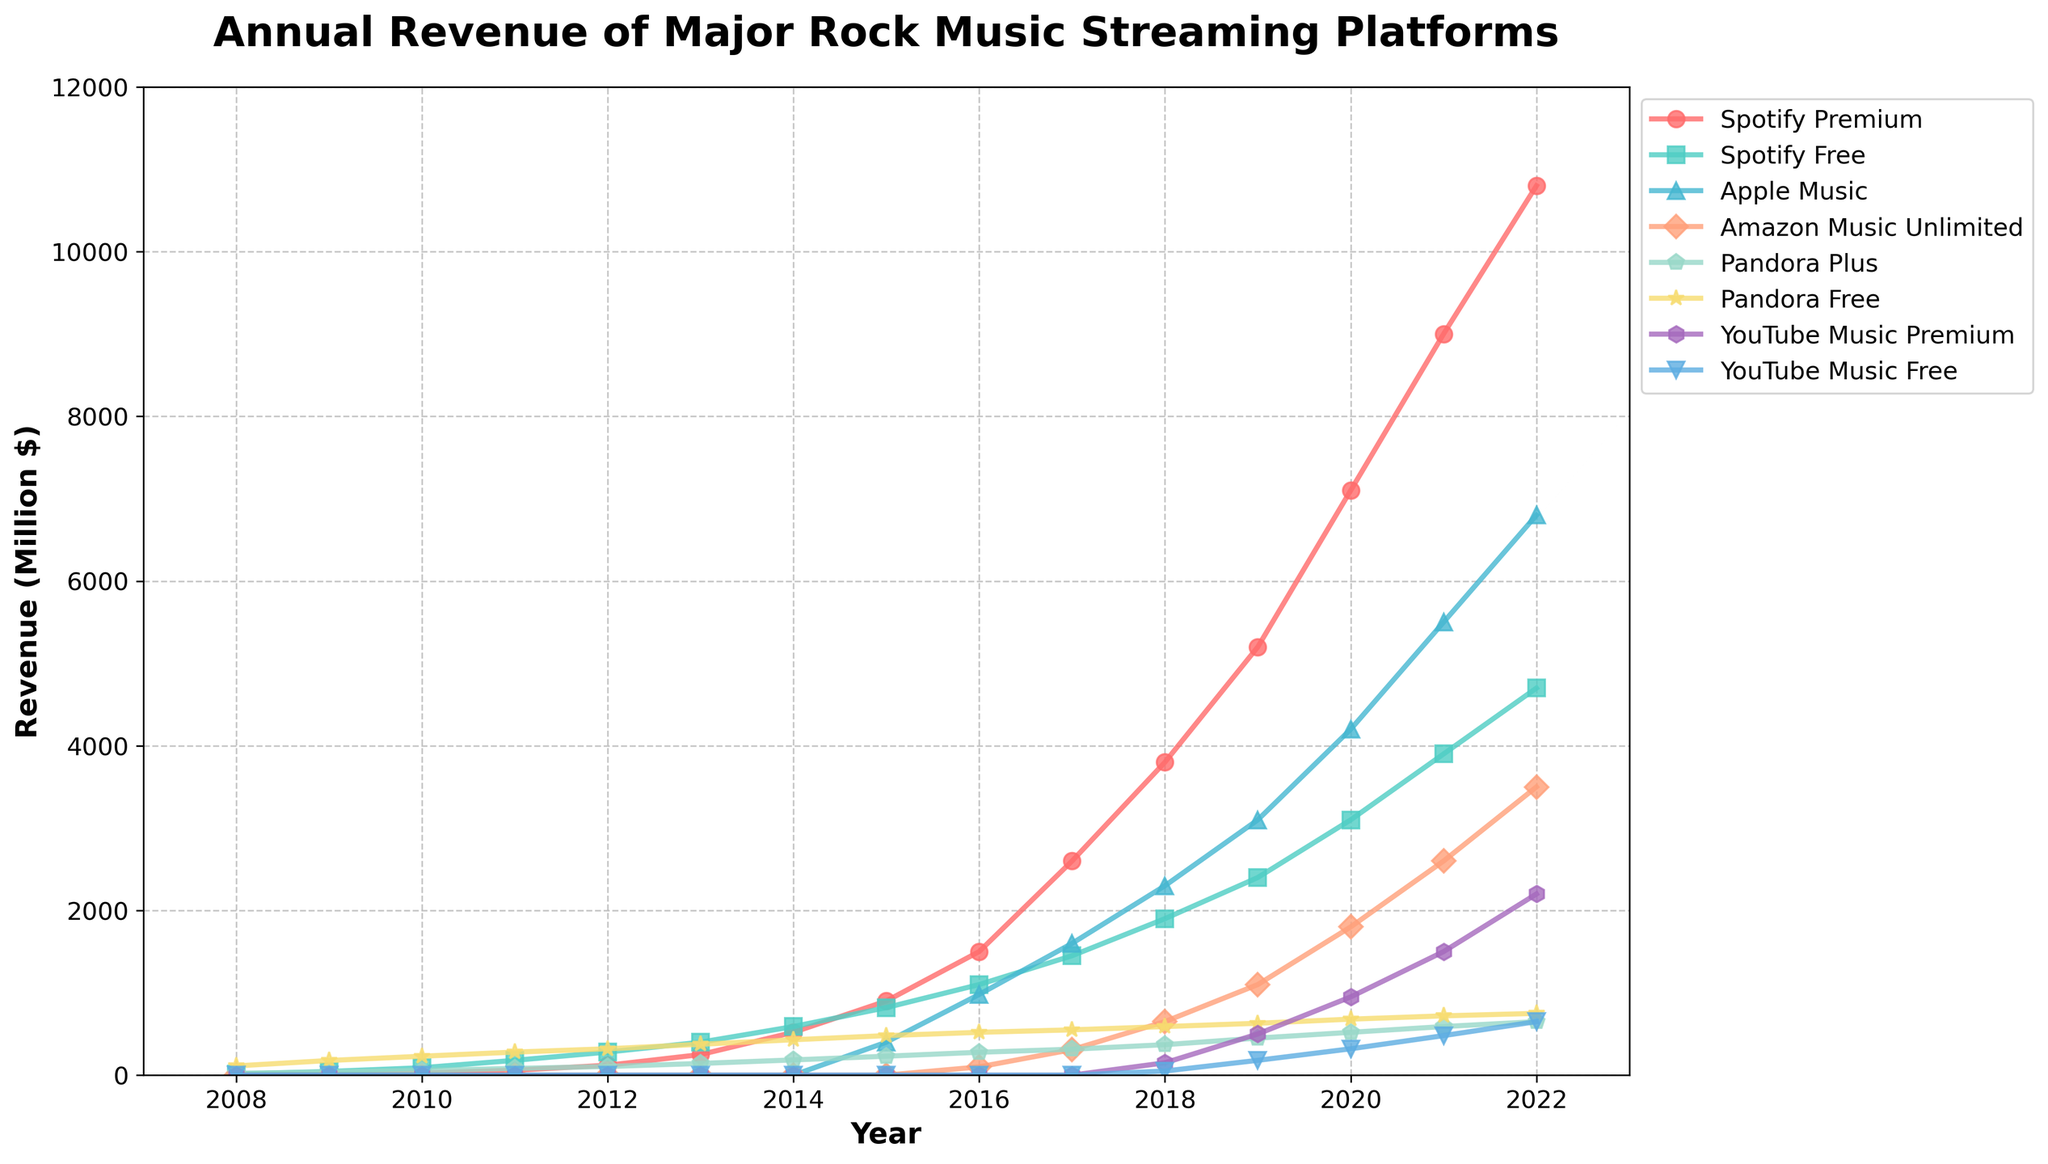What was the total revenue of Spotify in 2022? Spotify Premium had a revenue of 10800 million dollars and Spotify Free had a revenue of 4700 million dollars in 2022. Adding these together, the total revenue of Spotify in 2022 is 10800 + 4700 = 15500 million dollars.
Answer: 15500 million dollars Which platform had the highest revenue in 2020, and what was the amount? Checking each platform's revenue for 2020, Spotify Premium had the highest revenue of 7100 million dollars.
Answer: Spotify Premium, 7100 million dollars What is the difference in revenue between YouTube Music Premium and YouTube Music Free in 2021? In 2021, YouTube Music Premium had a revenue of 1500 million dollars, and YouTube Music Free had a revenue of 480 million dollars. The difference is 1500 - 480 = 1020 million dollars.
Answer: 1020 million dollars How did the revenue of Apple Music change from 2015 to 2022? In 2015, Apple Music's revenue was 400 million dollars. By 2022, it increased to 6800 million dollars. The change is 6800 - 400 = 6400 million dollars.
Answer: Increased by 6400 million dollars Which platform had the smallest revenue increase between 2019 and 2020? Comparing each platform's revenue increase: 
Spotify Premium (7100 - 5200 = 1900), 
Spotify Free (3100 - 2400 = 700), 
Apple Music (4200 - 3100 = 1100), 
Amazon Music Unlimited (1800 - 1100 = 700), 
Pandora Plus (520 - 450 = 70), 
Pandora Free (680 - 630 = 50), 
YouTube Music Premium (950 - 500 = 450), 
YouTube Music Free (320 - 180 = 140). 
Pandora Free had the smallest revenue increase of 50 million dollars.
Answer: Pandora Free, 50 million dollars Between 2008 and 2014, how many platforms had a zero revenue in each year? Analyzing the data: 
2008: Apple Music, Amazon Music Unlimited, YouTube Music Premium, YouTube Music Free (4 platforms),
2009: Apple Music, Amazon Music Unlimited, YouTube Music Premium, YouTube Music Free (4 platforms),
2010: Apple Music, Amazon Music Unlimited, YouTube Music Premium, YouTube Music Free (4 platforms),
2011: Apple Music, Amazon Music Unlimited, YouTube Music Premium, YouTube Music Free (4 platforms),
2012: Apple Music, Amazon Music Unlimited, YouTube Music Premium, YouTube Music Free (4 platforms),
2013: Apple Music, Amazon Music Unlimited, YouTube Music Premium, YouTube Music Free (4 platforms),
2014: Apple Music, Amazon Music Unlimited, YouTube Music Premium, YouTube Music Free (4 platforms). 
Thus, 4 platforms had zero revenue in each of these years.
Answer: 4 platforms What was the average annual revenue of Pandora Plus from 2008 to 2022? Summing the revenue for each year: 23 + 38 + 56 + 82 + 105 + 142 + 185 + 230 + 278 + 315 + 370 + 450 + 520 + 590 + 650 = 4034 million dollars. The period from 2008 to 2022 is 15 years. The average annual revenue is 4034 / 15 = 268.93 million dollars.
Answer: 268.93 million dollars Which year saw the largest revenue jump for Spotify Premium, and what was the amount of the increase? Comparing the year-on-year increases: 
2009 (12 - 5 = 7), 
2010 (25 - 12 = 13), 
2011 (60 - 25 = 35), 
2012 (120 - 60 = 60), 
2013 (250 - 120 = 130), 
2014 (520 - 250 = 270), 
2015 (900 - 520 = 380), 
2016 (1500 - 900 = 600), 
2017 (2600 - 1500 = 1100), 
2018 (3800 - 2600 = 1200), 
2019 (5200 - 3800 = 1400), 
2020 (7100 - 5200 = 1900), 
2021 (9000 - 7100 = 1900), 
2022 (10800 - 9000 = 1800). 
The largest revenue jump was in 2020, with an increase of 1900 million dollars.
Answer: 2020, 1900 million dollars 